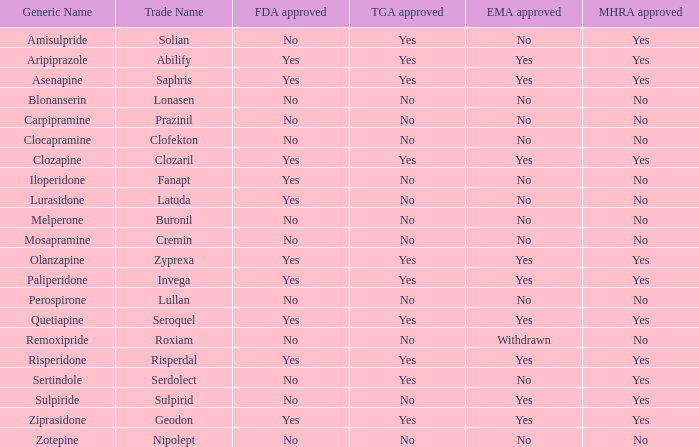Is Blonanserin MHRA approved? No. 